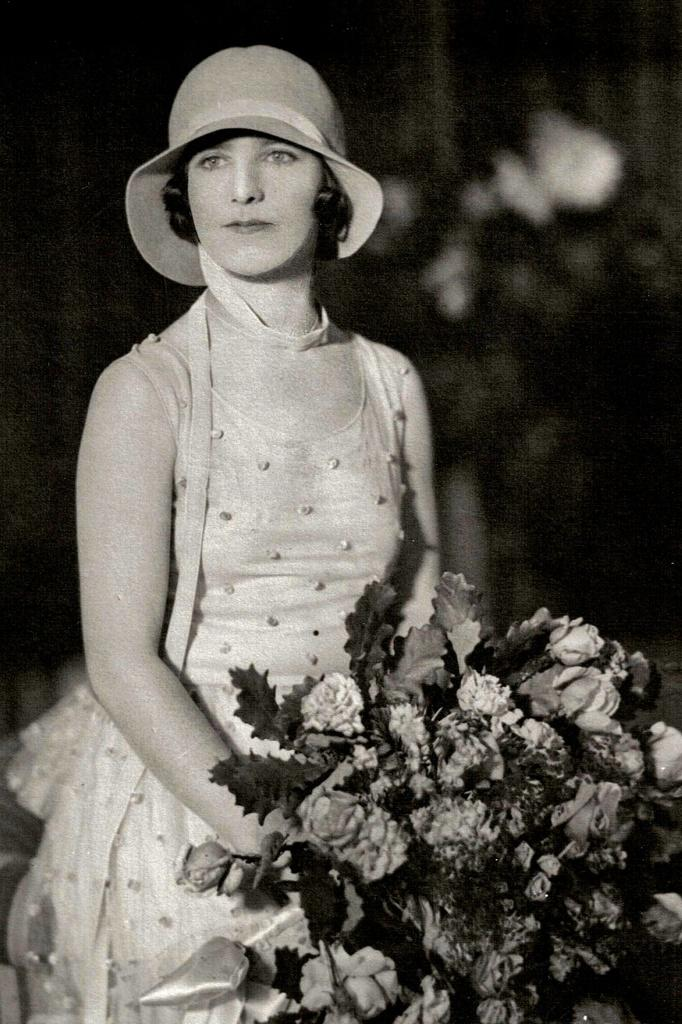Who is the main subject in the image? There is a lady in the image. What is the lady holding in the image? The lady is holding a bouquet. What accessory is the lady wearing in the image? The lady is wearing a hat. Can you describe the background of the image? The background of the image is blurred. What is the value of the bouquet in the image? The image does not provide any information about the value of the bouquet. 